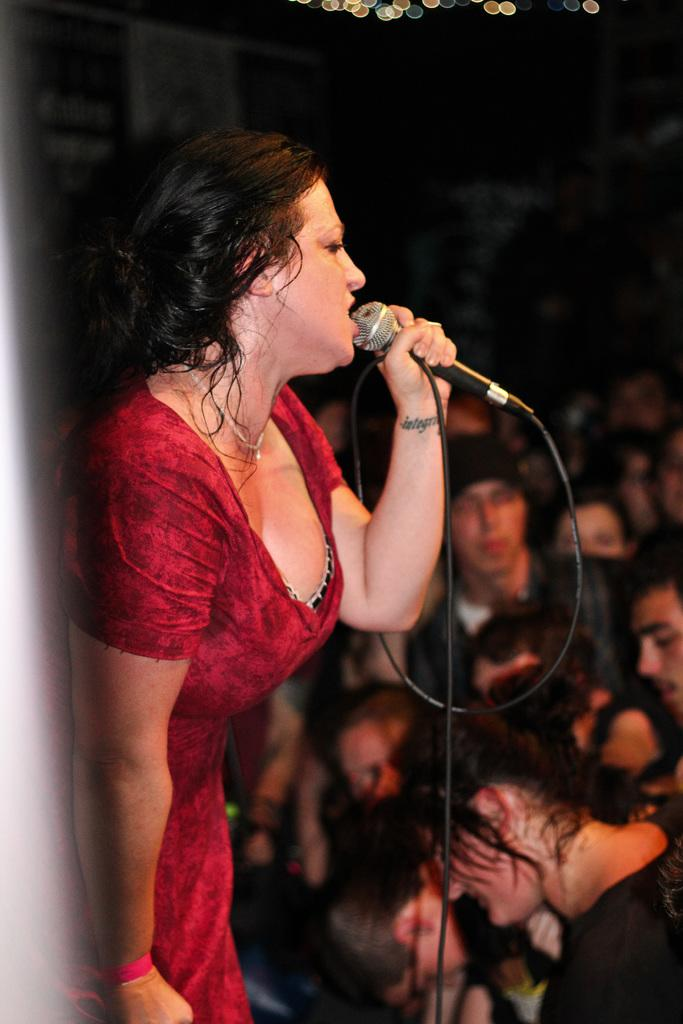What is the main subject of the image? The main subject of the image is a woman. What is the woman doing in the image? The woman is standing and singing into a black microphone. Can you describe the microphone the woman is holding? The microphone is black. What can be seen in the background of the image? There are people in the background of the image. What type of brush can be seen on the hill in the image? There is no brush or hill present in the image. What kind of station is visible in the background of the image? There is no station visible in the background of the image. 